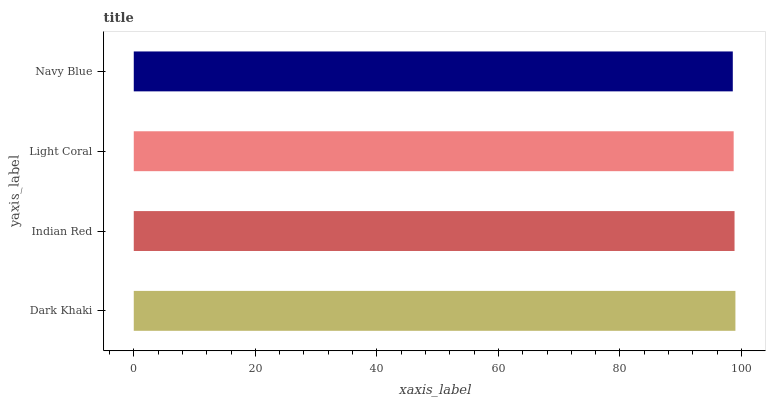Is Navy Blue the minimum?
Answer yes or no. Yes. Is Dark Khaki the maximum?
Answer yes or no. Yes. Is Indian Red the minimum?
Answer yes or no. No. Is Indian Red the maximum?
Answer yes or no. No. Is Dark Khaki greater than Indian Red?
Answer yes or no. Yes. Is Indian Red less than Dark Khaki?
Answer yes or no. Yes. Is Indian Red greater than Dark Khaki?
Answer yes or no. No. Is Dark Khaki less than Indian Red?
Answer yes or no. No. Is Indian Red the high median?
Answer yes or no. Yes. Is Light Coral the low median?
Answer yes or no. Yes. Is Navy Blue the high median?
Answer yes or no. No. Is Navy Blue the low median?
Answer yes or no. No. 